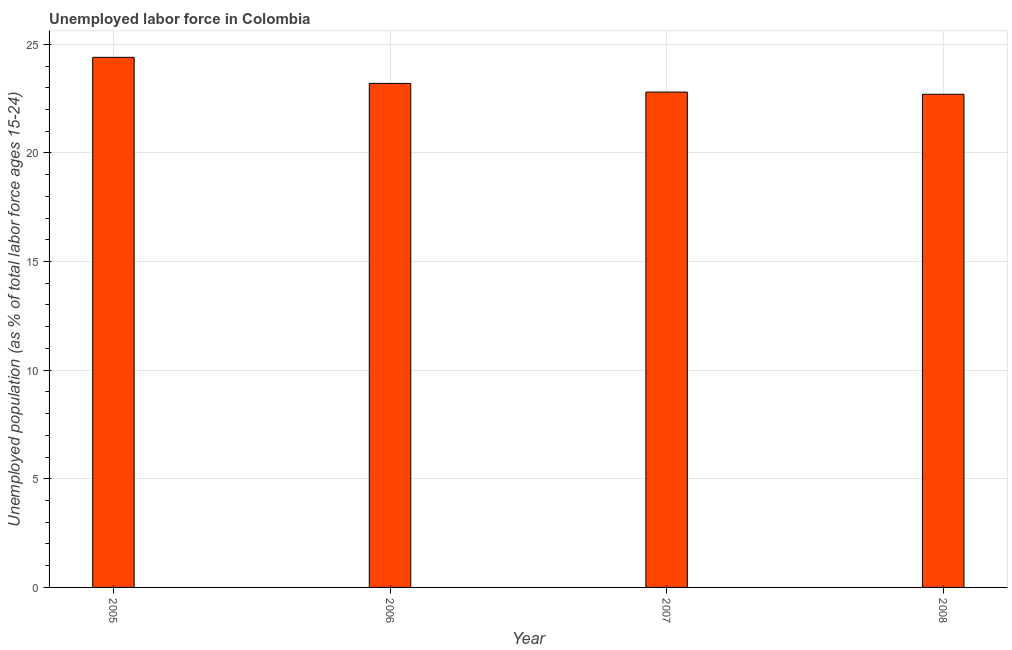Does the graph contain any zero values?
Your answer should be compact. No. Does the graph contain grids?
Provide a succinct answer. Yes. What is the title of the graph?
Your answer should be compact. Unemployed labor force in Colombia. What is the label or title of the Y-axis?
Your response must be concise. Unemployed population (as % of total labor force ages 15-24). What is the total unemployed youth population in 2008?
Provide a succinct answer. 22.7. Across all years, what is the maximum total unemployed youth population?
Give a very brief answer. 24.4. Across all years, what is the minimum total unemployed youth population?
Offer a very short reply. 22.7. In which year was the total unemployed youth population maximum?
Provide a short and direct response. 2005. What is the sum of the total unemployed youth population?
Your response must be concise. 93.1. What is the difference between the total unemployed youth population in 2005 and 2008?
Offer a terse response. 1.7. What is the average total unemployed youth population per year?
Offer a terse response. 23.27. In how many years, is the total unemployed youth population greater than 2 %?
Provide a succinct answer. 4. Do a majority of the years between 2008 and 2005 (inclusive) have total unemployed youth population greater than 5 %?
Your answer should be compact. Yes. What is the ratio of the total unemployed youth population in 2005 to that in 2007?
Ensure brevity in your answer.  1.07. Is the total unemployed youth population in 2005 less than that in 2008?
Make the answer very short. No. Is the difference between the total unemployed youth population in 2006 and 2008 greater than the difference between any two years?
Keep it short and to the point. No. What is the difference between the highest and the lowest total unemployed youth population?
Offer a terse response. 1.7. Are all the bars in the graph horizontal?
Offer a terse response. No. Are the values on the major ticks of Y-axis written in scientific E-notation?
Offer a terse response. No. What is the Unemployed population (as % of total labor force ages 15-24) in 2005?
Offer a terse response. 24.4. What is the Unemployed population (as % of total labor force ages 15-24) of 2006?
Your response must be concise. 23.2. What is the Unemployed population (as % of total labor force ages 15-24) of 2007?
Offer a terse response. 22.8. What is the Unemployed population (as % of total labor force ages 15-24) in 2008?
Make the answer very short. 22.7. What is the difference between the Unemployed population (as % of total labor force ages 15-24) in 2006 and 2007?
Offer a terse response. 0.4. What is the difference between the Unemployed population (as % of total labor force ages 15-24) in 2007 and 2008?
Ensure brevity in your answer.  0.1. What is the ratio of the Unemployed population (as % of total labor force ages 15-24) in 2005 to that in 2006?
Offer a very short reply. 1.05. What is the ratio of the Unemployed population (as % of total labor force ages 15-24) in 2005 to that in 2007?
Give a very brief answer. 1.07. What is the ratio of the Unemployed population (as % of total labor force ages 15-24) in 2005 to that in 2008?
Ensure brevity in your answer.  1.07. 